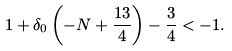<formula> <loc_0><loc_0><loc_500><loc_500>1 + \delta _ { 0 } \left ( - N + \frac { 1 3 } { 4 } \right ) - \frac { 3 } { 4 } < - 1 .</formula> 